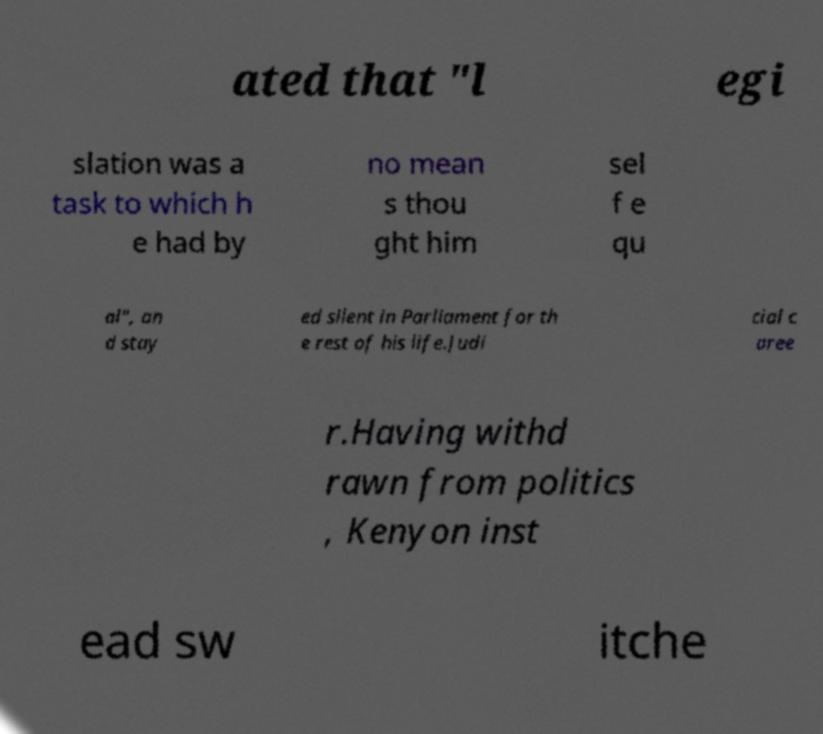Can you read and provide the text displayed in the image?This photo seems to have some interesting text. Can you extract and type it out for me? ated that "l egi slation was a task to which h e had by no mean s thou ght him sel f e qu al", an d stay ed silent in Parliament for th e rest of his life.Judi cial c aree r.Having withd rawn from politics , Kenyon inst ead sw itche 